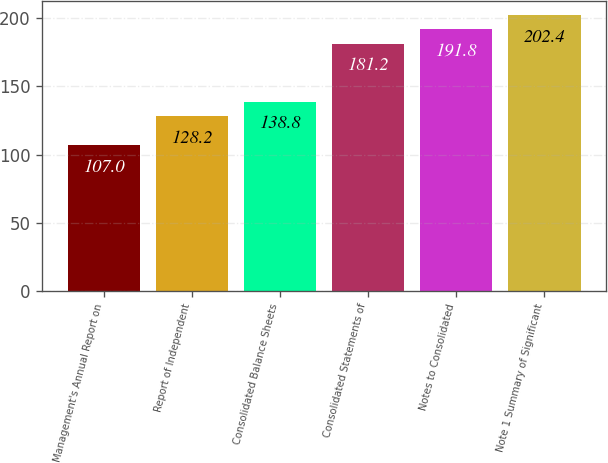Convert chart to OTSL. <chart><loc_0><loc_0><loc_500><loc_500><bar_chart><fcel>Management's Annual Report on<fcel>Report of Independent<fcel>Consolidated Balance Sheets<fcel>Consolidated Statements of<fcel>Notes to Consolidated<fcel>Note 1 Summary of Significant<nl><fcel>107<fcel>128.2<fcel>138.8<fcel>181.2<fcel>191.8<fcel>202.4<nl></chart> 